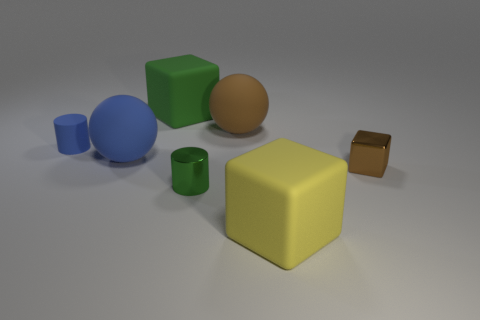Add 2 large blue matte things. How many objects exist? 9 Subtract all spheres. How many objects are left? 5 Add 1 tiny brown metallic objects. How many tiny brown metallic objects exist? 2 Subtract 0 cyan cylinders. How many objects are left? 7 Subtract all big brown spheres. Subtract all brown matte things. How many objects are left? 5 Add 6 large yellow matte things. How many large yellow matte things are left? 7 